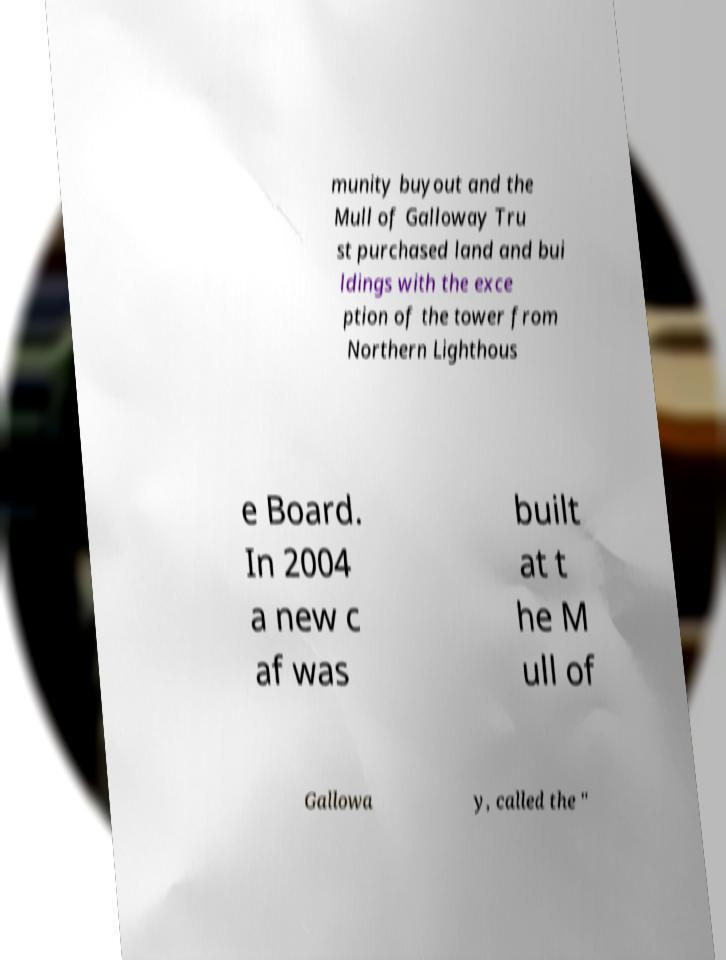For documentation purposes, I need the text within this image transcribed. Could you provide that? munity buyout and the Mull of Galloway Tru st purchased land and bui ldings with the exce ption of the tower from Northern Lighthous e Board. In 2004 a new c af was built at t he M ull of Gallowa y, called the " 